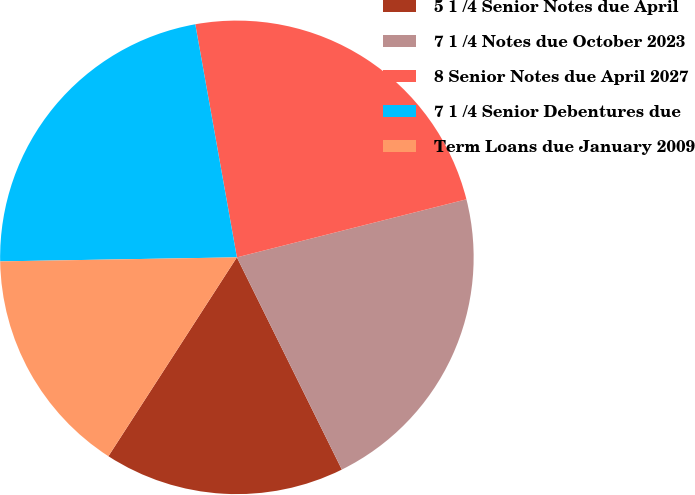Convert chart. <chart><loc_0><loc_0><loc_500><loc_500><pie_chart><fcel>5 1 /4 Senior Notes due April<fcel>7 1 /4 Notes due October 2023<fcel>8 Senior Notes due April 2027<fcel>7 1 /4 Senior Debentures due<fcel>Term Loans due January 2009<nl><fcel>16.44%<fcel>21.63%<fcel>23.87%<fcel>22.46%<fcel>15.6%<nl></chart> 